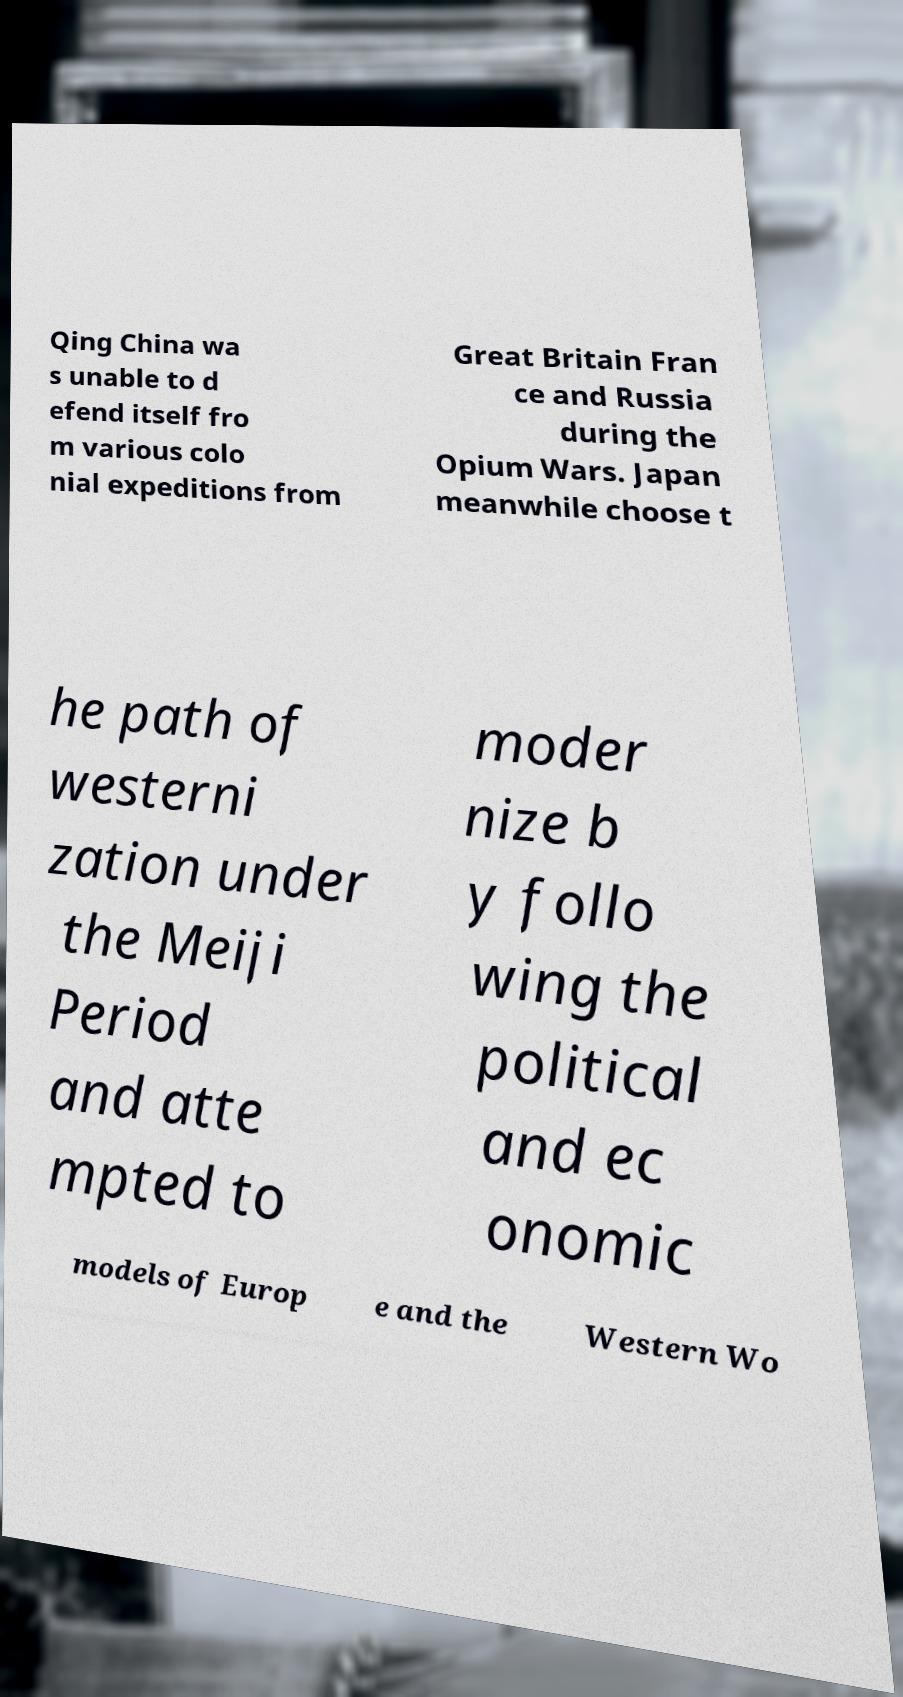Please read and relay the text visible in this image. What does it say? Qing China wa s unable to d efend itself fro m various colo nial expeditions from Great Britain Fran ce and Russia during the Opium Wars. Japan meanwhile choose t he path of westerni zation under the Meiji Period and atte mpted to moder nize b y follo wing the political and ec onomic models of Europ e and the Western Wo 